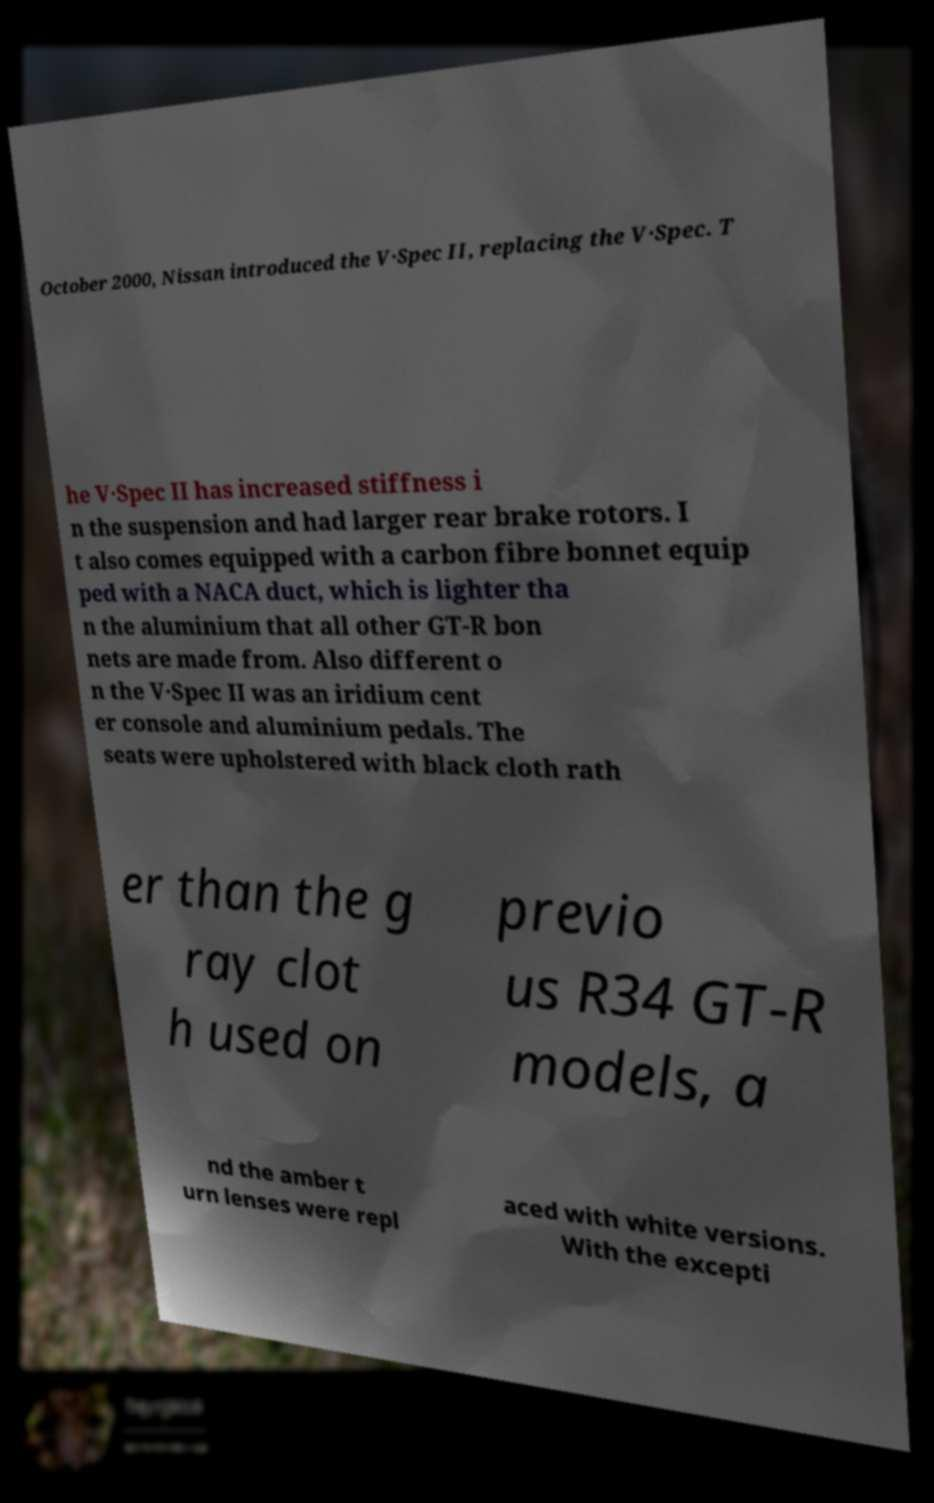Could you assist in decoding the text presented in this image and type it out clearly? October 2000, Nissan introduced the V·Spec II, replacing the V·Spec. T he V·Spec II has increased stiffness i n the suspension and had larger rear brake rotors. I t also comes equipped with a carbon fibre bonnet equip ped with a NACA duct, which is lighter tha n the aluminium that all other GT-R bon nets are made from. Also different o n the V·Spec II was an iridium cent er console and aluminium pedals. The seats were upholstered with black cloth rath er than the g ray clot h used on previo us R34 GT-R models, a nd the amber t urn lenses were repl aced with white versions. With the excepti 